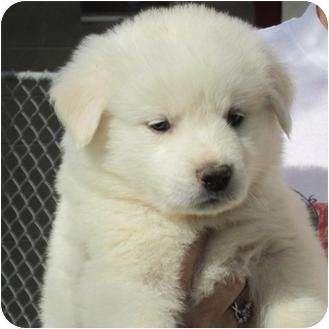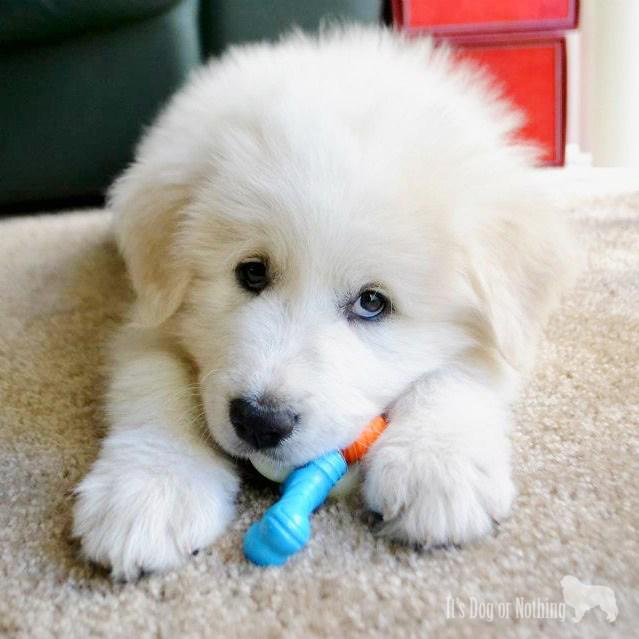The first image is the image on the left, the second image is the image on the right. Considering the images on both sides, is "There are no more than two dogs." valid? Answer yes or no. Yes. The first image is the image on the left, the second image is the image on the right. Considering the images on both sides, is "There is exactly one dog in each image." valid? Answer yes or no. Yes. 